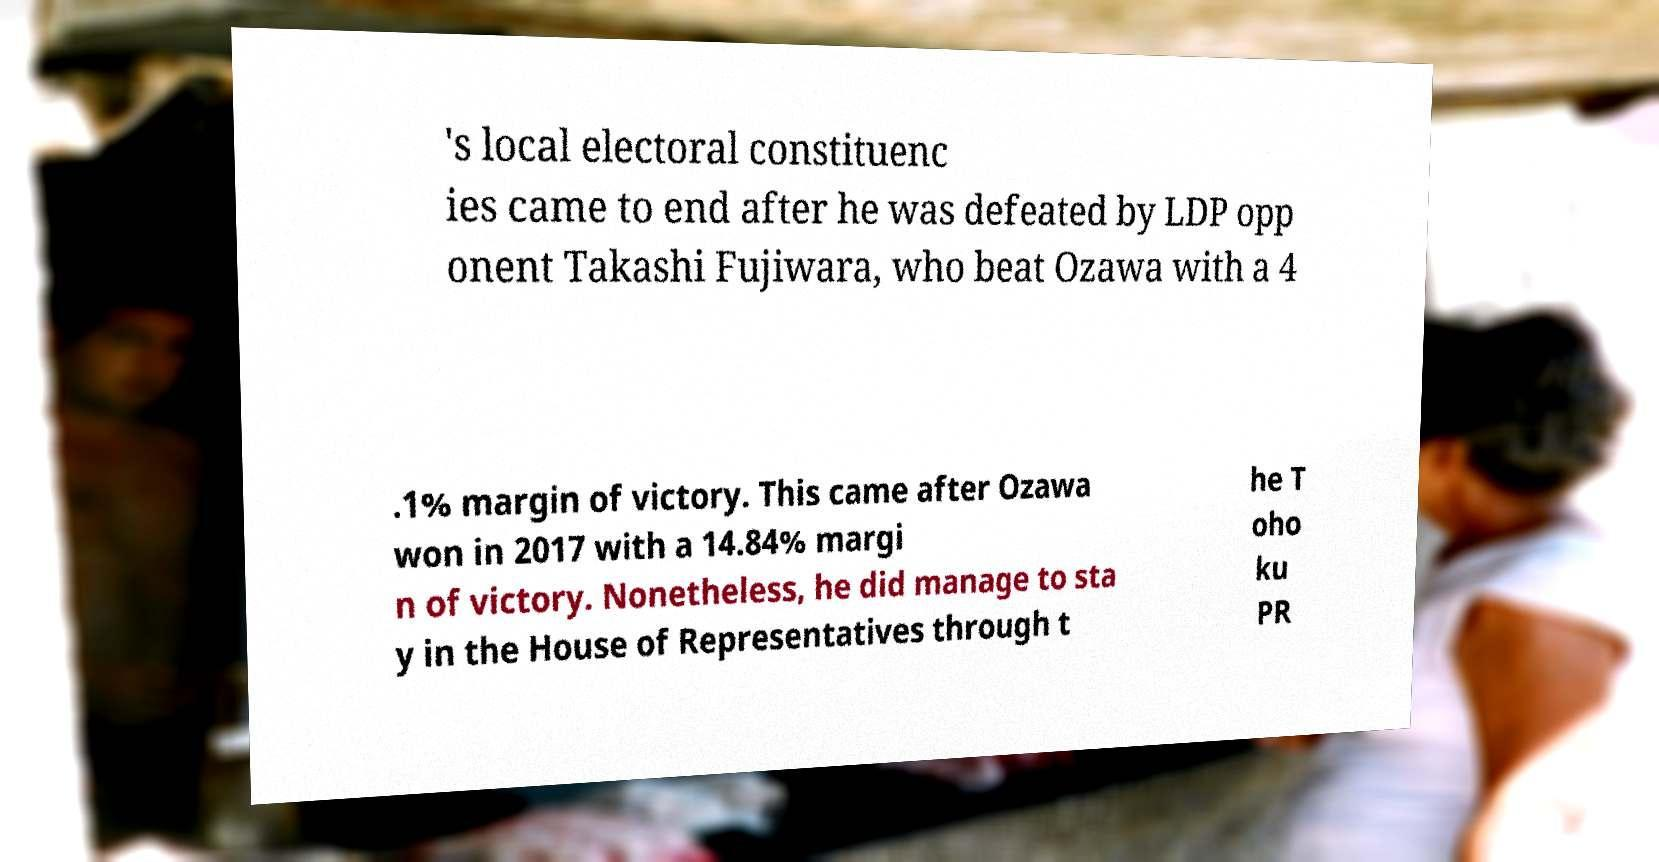Could you assist in decoding the text presented in this image and type it out clearly? 's local electoral constituenc ies came to end after he was defeated by LDP opp onent Takashi Fujiwara, who beat Ozawa with a 4 .1% margin of victory. This came after Ozawa won in 2017 with a 14.84% margi n of victory. Nonetheless, he did manage to sta y in the House of Representatives through t he T oho ku PR 